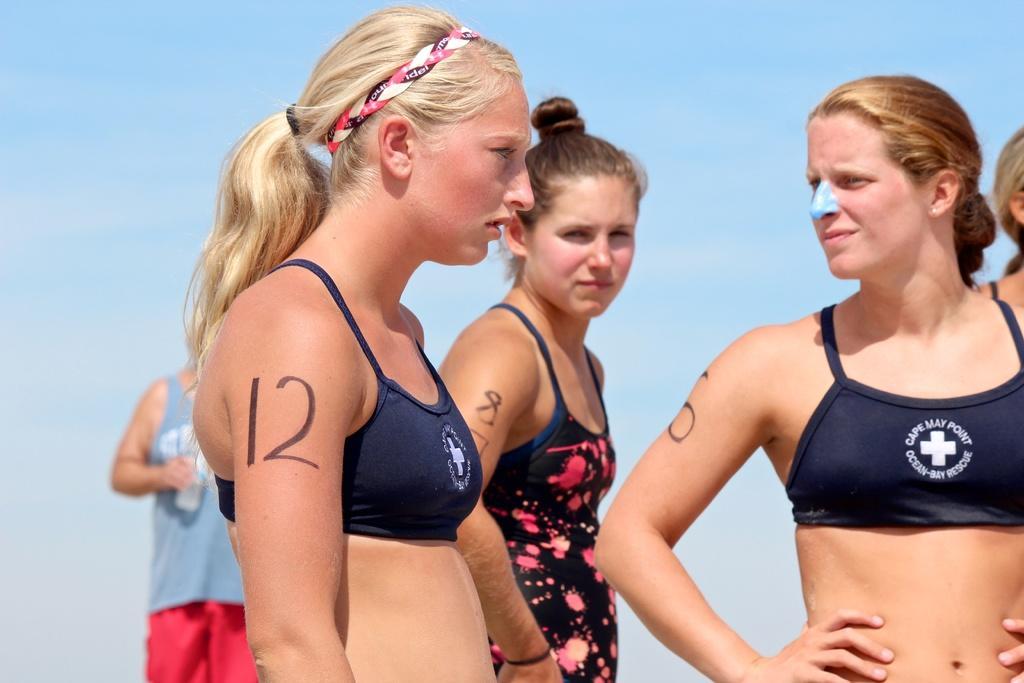Please provide a concise description of this image. In the image there are few ladies standing. On their hands there are numbers. Behind them there is sky. 